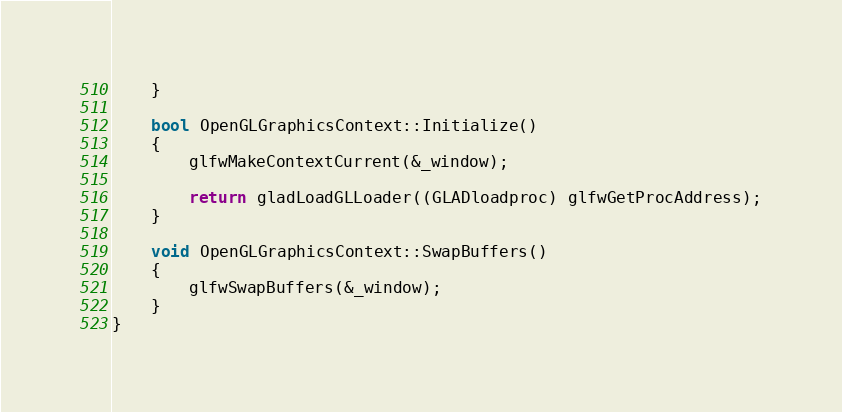Convert code to text. <code><loc_0><loc_0><loc_500><loc_500><_C++_>    }

    bool OpenGLGraphicsContext::Initialize()
    {
        glfwMakeContextCurrent(&_window);

        return gladLoadGLLoader((GLADloadproc) glfwGetProcAddress);
    }

    void OpenGLGraphicsContext::SwapBuffers()
    {
        glfwSwapBuffers(&_window);
    }
}</code> 